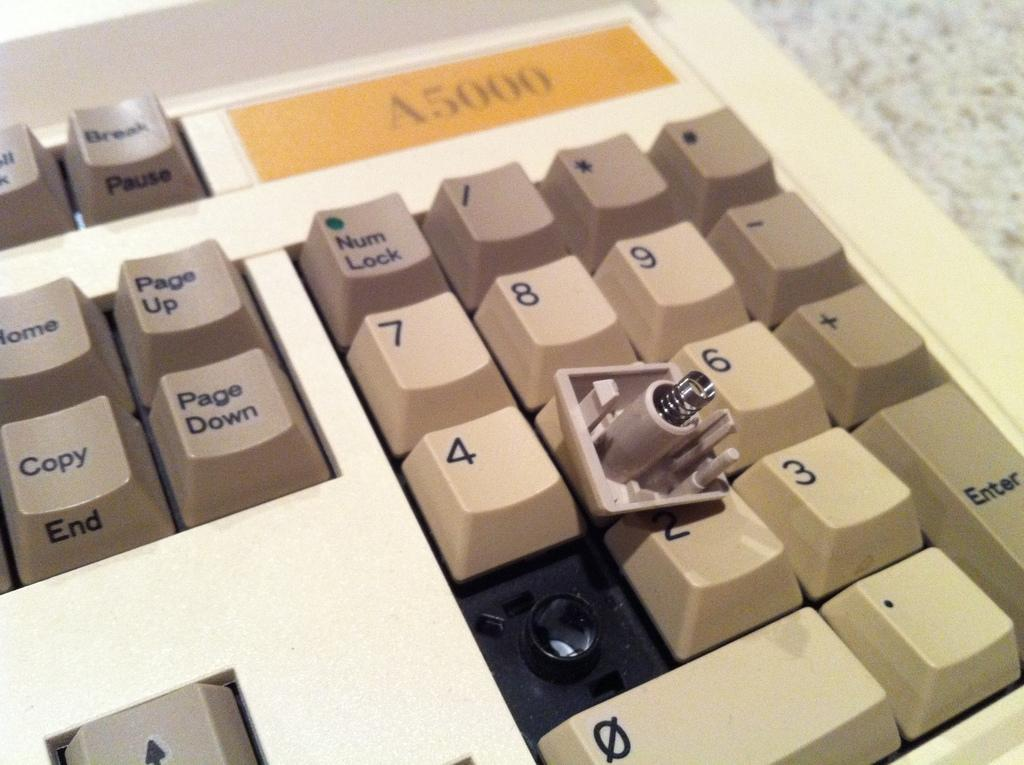<image>
Provide a brief description of the given image. a keyboard that has a label that says 'A5000' on it 